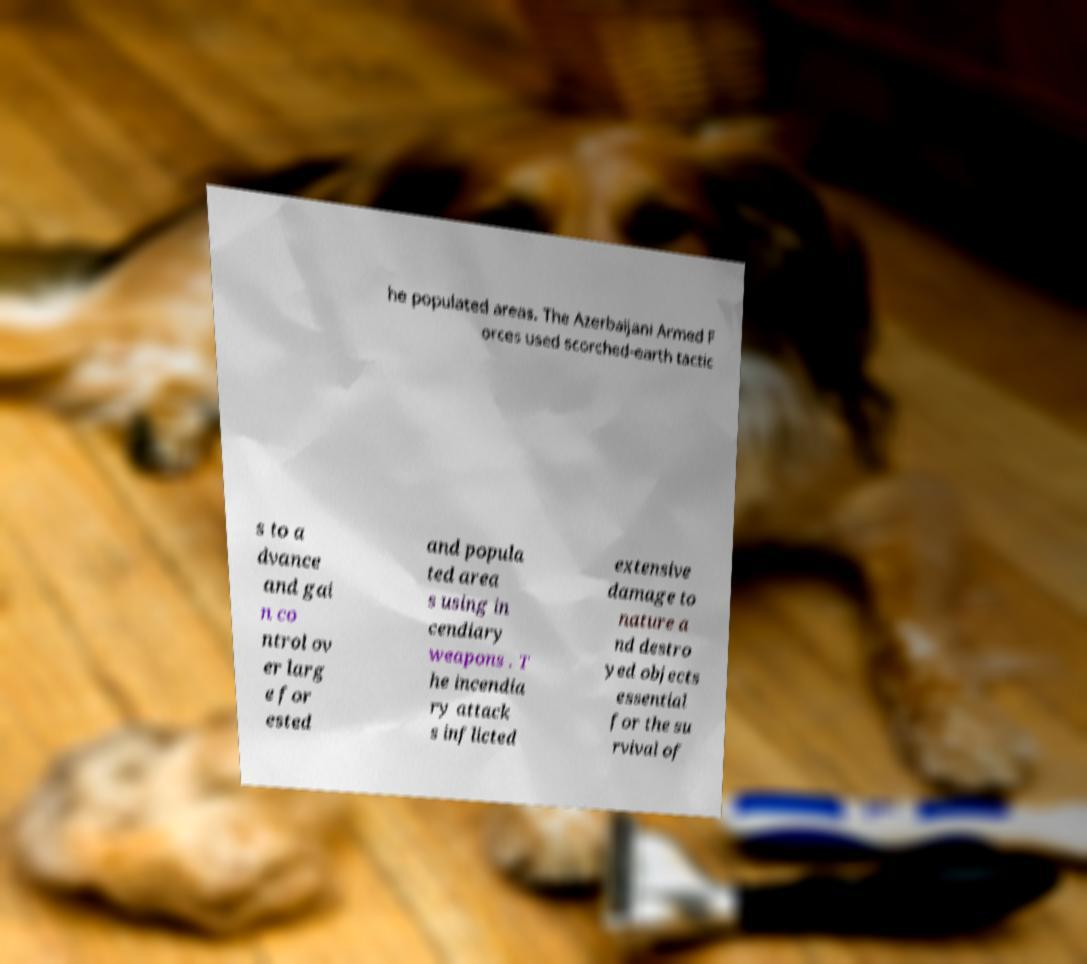Can you read and provide the text displayed in the image?This photo seems to have some interesting text. Can you extract and type it out for me? he populated areas. The Azerbaijani Armed F orces used scorched-earth tactic s to a dvance and gai n co ntrol ov er larg e for ested and popula ted area s using in cendiary weapons . T he incendia ry attack s inflicted extensive damage to nature a nd destro yed objects essential for the su rvival of 